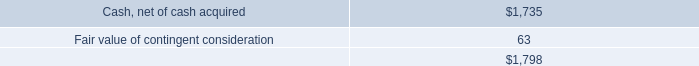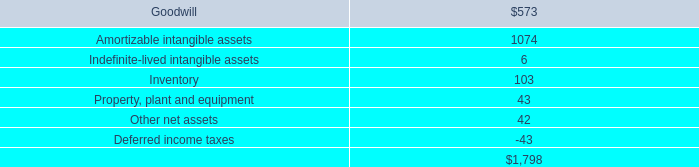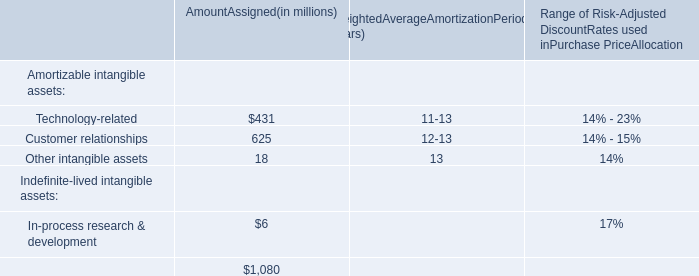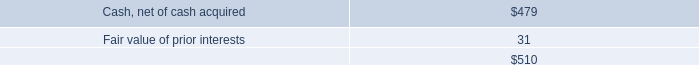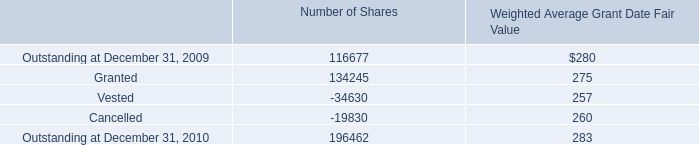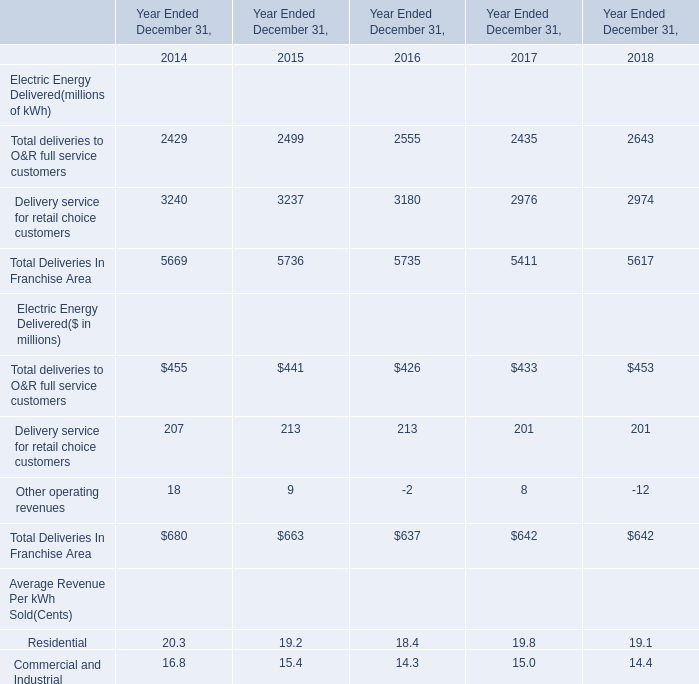what is the performance shares granted as a percent of the total number of granted shares in 2010? 
Computations: (1020 / 134245)
Answer: 0.0076. 